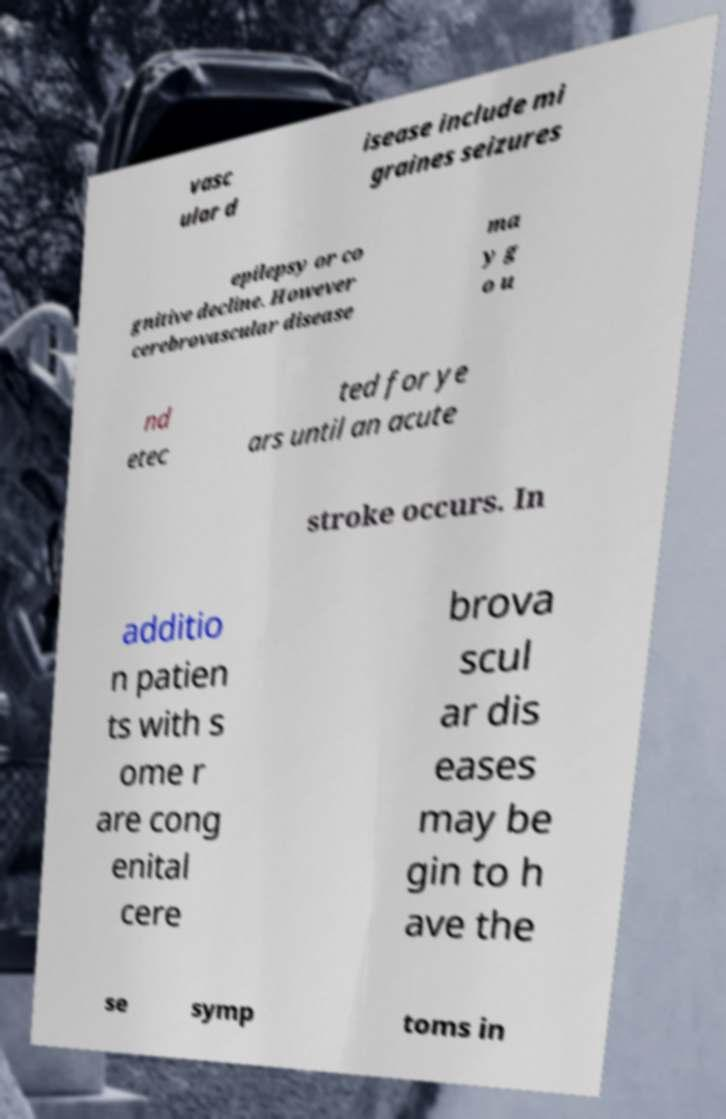Could you assist in decoding the text presented in this image and type it out clearly? vasc ular d isease include mi graines seizures epilepsy or co gnitive decline. However cerebrovascular disease ma y g o u nd etec ted for ye ars until an acute stroke occurs. In additio n patien ts with s ome r are cong enital cere brova scul ar dis eases may be gin to h ave the se symp toms in 